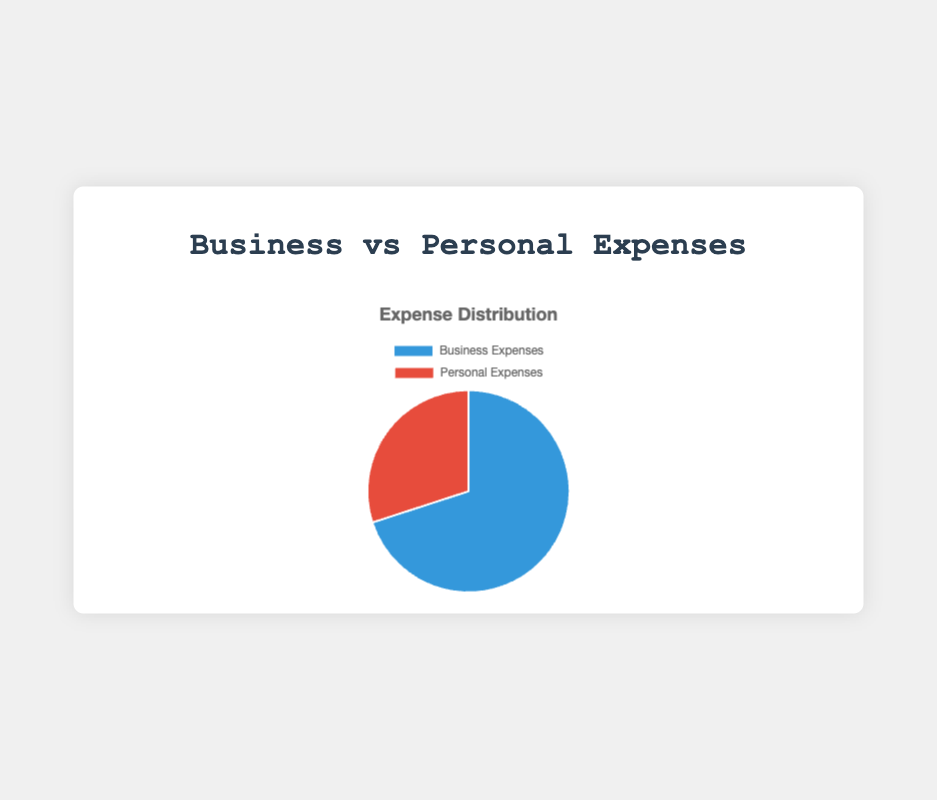What percentage of the total expenses are business expenses? First, add up the total of business and personal expenses: $70,000 + $30,000 = $100,000. The business expenses amount is $70,000, so the percentage is ($70,000 / $100,000) * 100% = 70%.
Answer: 70% Which category has higher expenses, business or personal? The pie chart shows that business expenses are $70,000 and personal expenses are $30,000, $70,000 is higher than $30,000.
Answer: Business How much more are business expenses compared to personal expenses? The difference between business expenses and personal expenses is $70,000 - $30,000 = $40,000.
Answer: $40,000 What is the ratio of business expenses to personal expenses? The ratio is found by dividing the business expenses by the personal expenses: $70,000 / $30,000 = 7/3 or approximately 2.33.
Answer: 7:3 or 2.33 If both categories of expenses were evenly distributed among 12 months, what would be the average monthly expense for each category? For business expenses: $70,000 / 12 = approximately $5833.33. For personal expenses: $30,000 / 12 = $2500.
Answer: $5833.33 (Business), $2500 (Personal) What's the difference in percentages between business and personal expenses? Business expenses are 70% and personal expenses are 30%. The difference in percentages is 70% - 30% = 40%.
Answer: 40% If business expenses were reduced by 10%, what would be the new percentage of total expenses for business and personal categories? Business expenses reduced by 10%: $70,000 * 0.1 = $7,000. New business expenses: $70,000 - $7,000 = $63,000. New total expenses: $63,000 + $30,000 = $93,000. New percentage for business: ($63,000 / $93,000) * 100% ≈ 67.74%. New percentage for personal: ($30,000 / $93,000) * 100% ≈ 32.26%.
Answer: 67.74% (Business), 32.26% (Personal) What color represents the personal expenses in the pie chart? The personal expenses are represented by the red segment of the pie chart.
Answer: Red If Alf's tax deduction rate is 20%, how much will Alf save in taxes from his business expenses? The tax saving is 20% of the business expenses: $70,000 * 0.2 = $14,000.
Answer: $14,000 